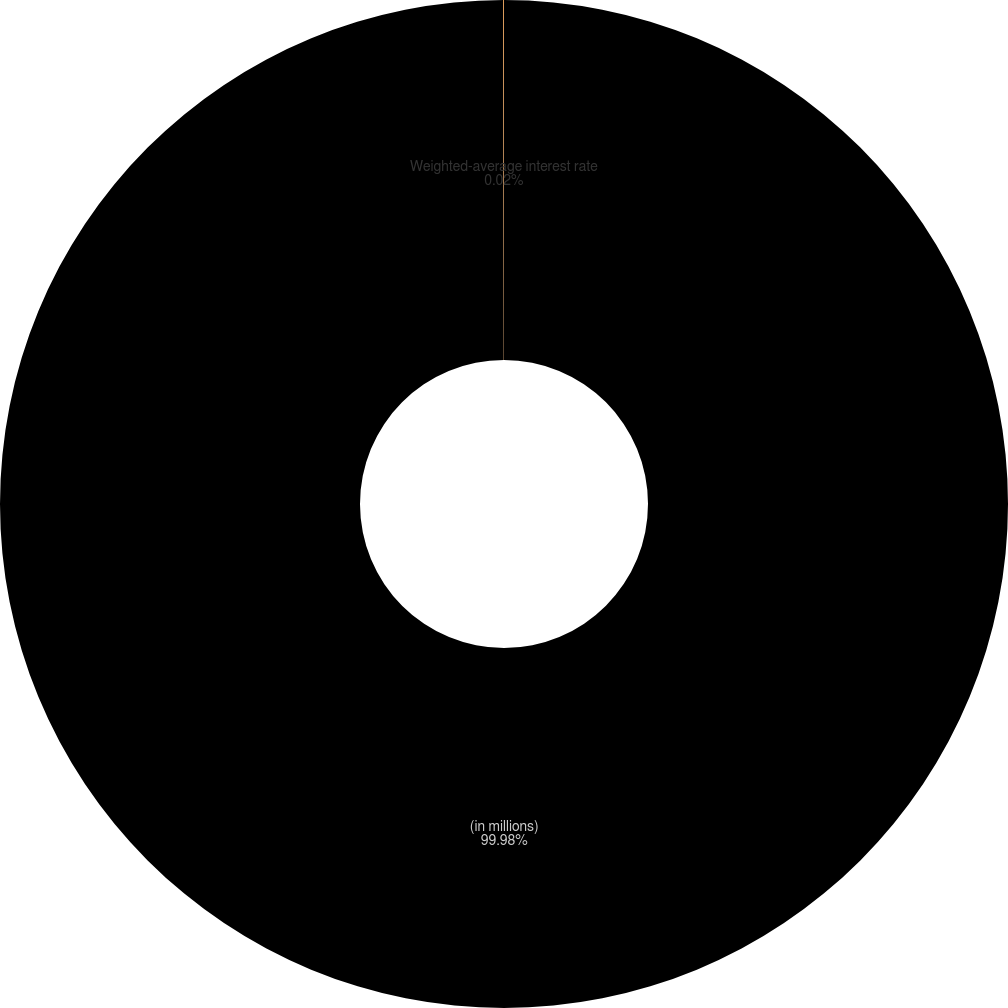Convert chart. <chart><loc_0><loc_0><loc_500><loc_500><pie_chart><fcel>(in millions)<fcel>Weighted-average interest rate<nl><fcel>99.98%<fcel>0.02%<nl></chart> 